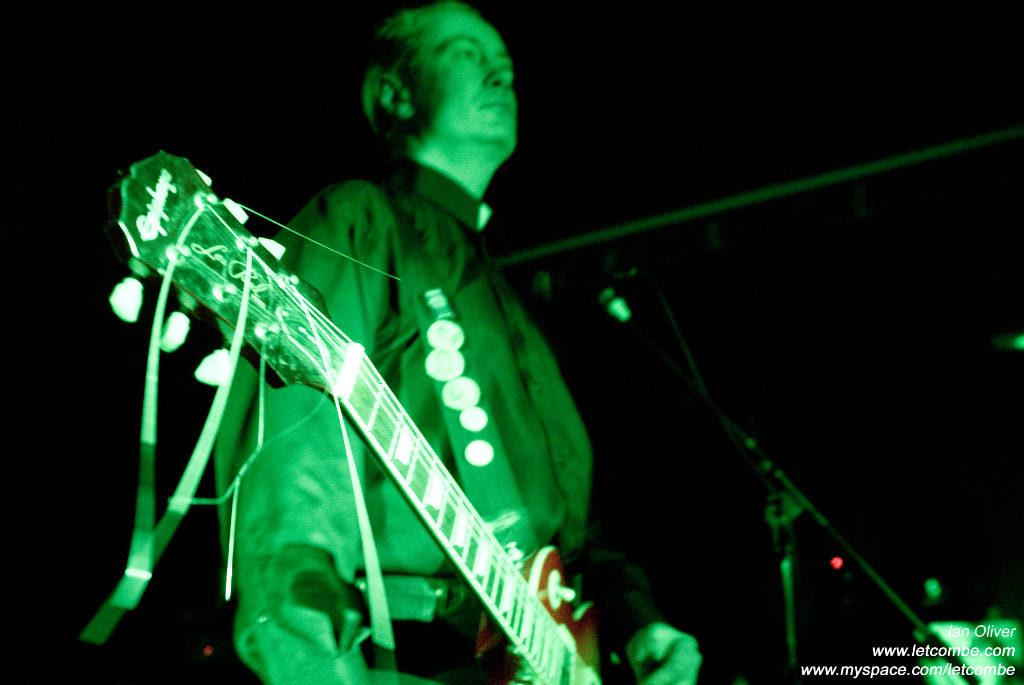Who is present in the image? There is a person in the image. What is the person doing in the image? The person is standing and playing musical instruments. What type of beef is being served at the concert in the image? There is no beef or concert present in the image; it only shows a person playing musical instruments while standing. 